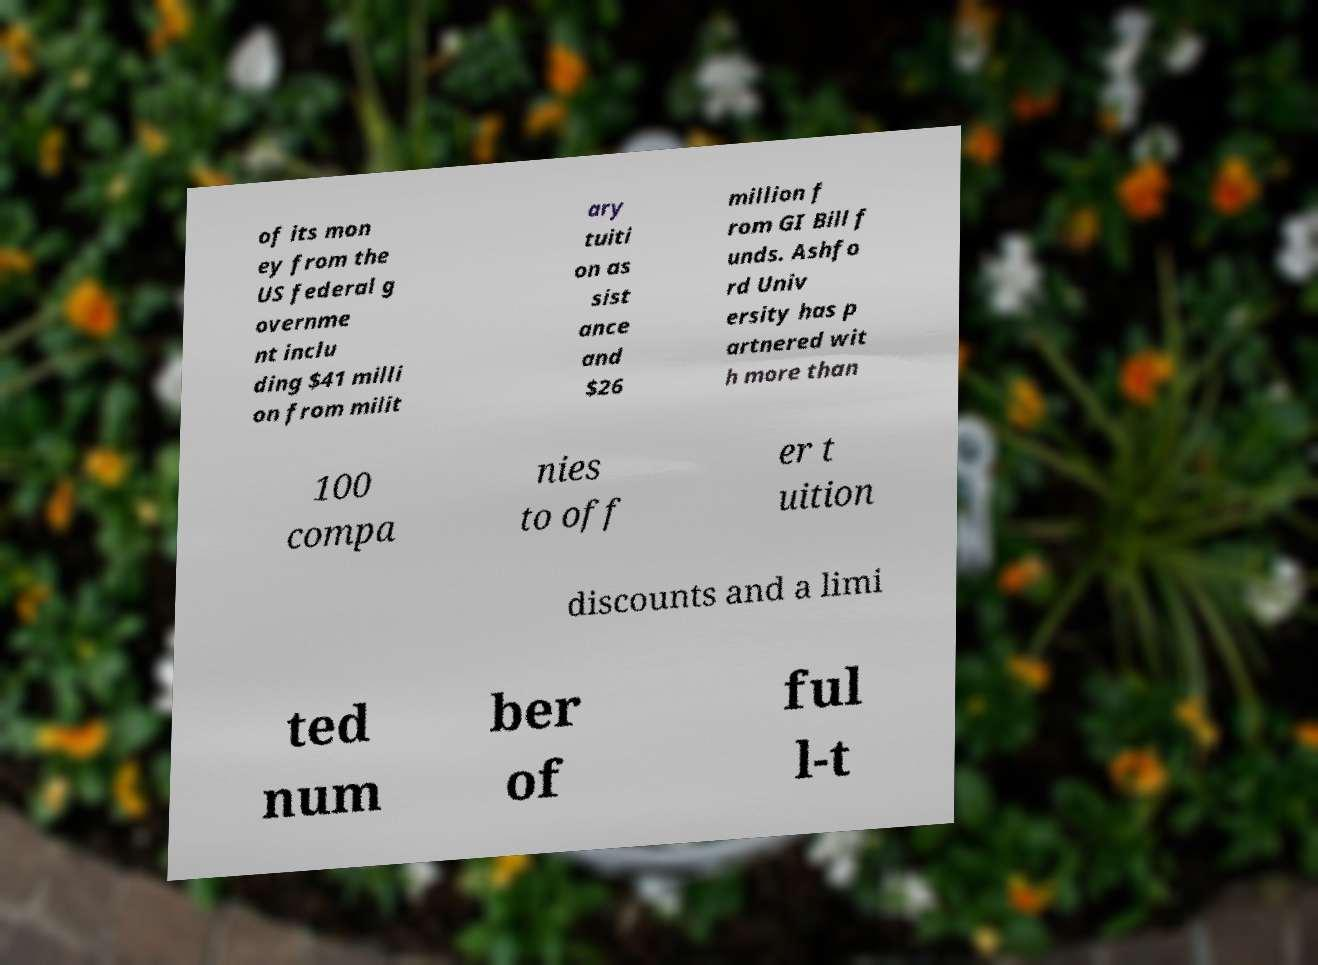Can you accurately transcribe the text from the provided image for me? of its mon ey from the US federal g overnme nt inclu ding $41 milli on from milit ary tuiti on as sist ance and $26 million f rom GI Bill f unds. Ashfo rd Univ ersity has p artnered wit h more than 100 compa nies to off er t uition discounts and a limi ted num ber of ful l-t 